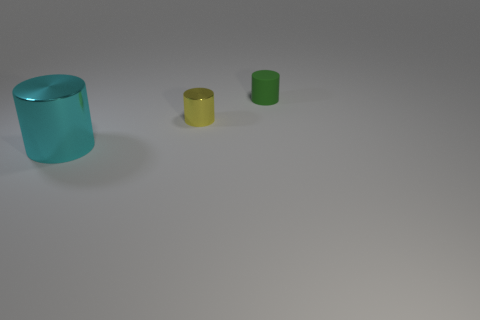Are there any other things that are made of the same material as the small green cylinder?
Keep it short and to the point. No. Is there any other thing that has the same size as the cyan thing?
Keep it short and to the point. No. What size is the cyan thing that is the same shape as the small green object?
Provide a succinct answer. Large. There is a shiny cylinder that is on the right side of the cyan cylinder; is it the same size as the cyan cylinder?
Give a very brief answer. No. What size is the cylinder that is both behind the big cyan shiny cylinder and in front of the green cylinder?
Make the answer very short. Small. Are there an equal number of metal cylinders on the left side of the small matte thing and tiny cylinders?
Offer a very short reply. Yes. The large thing has what color?
Your answer should be very brief. Cyan. What is the size of the cyan cylinder that is the same material as the small yellow thing?
Offer a terse response. Large. The cylinder that is the same material as the big cyan thing is what color?
Give a very brief answer. Yellow. Is there a yellow thing that has the same size as the matte cylinder?
Make the answer very short. Yes. 